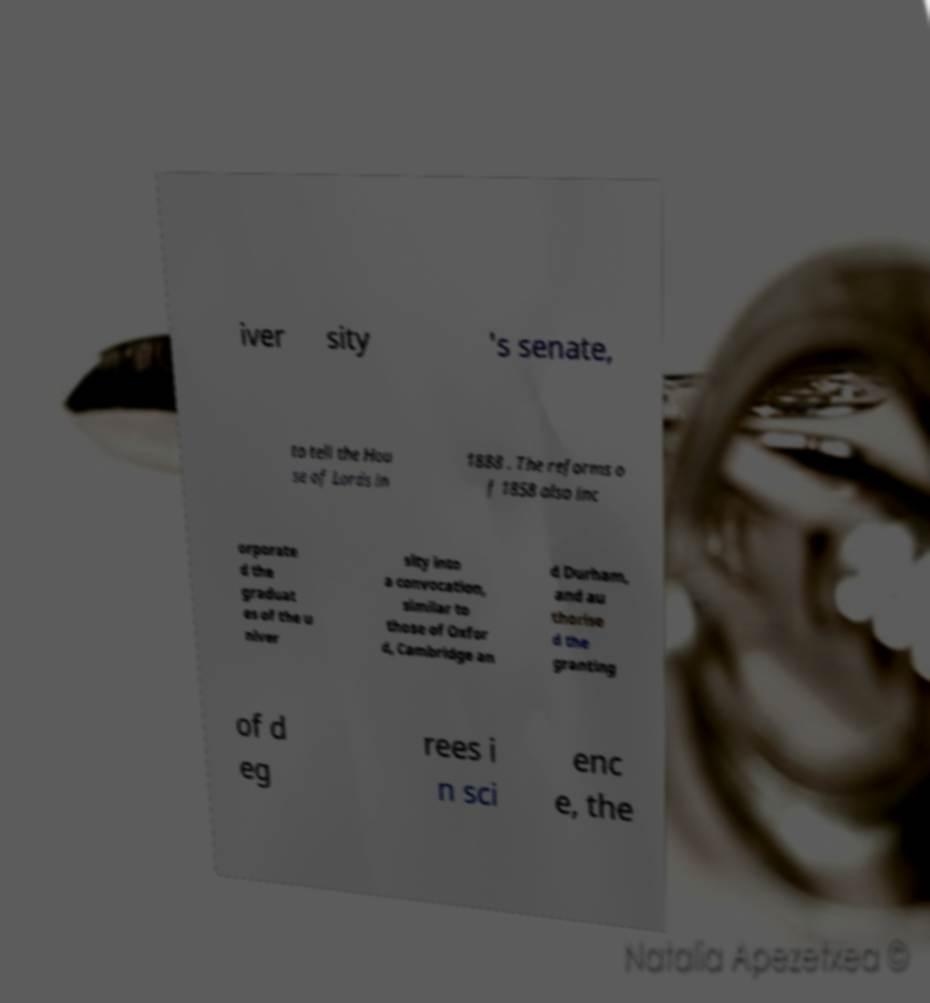What messages or text are displayed in this image? I need them in a readable, typed format. iver sity 's senate, to tell the Hou se of Lords in 1888 . The reforms o f 1858 also inc orporate d the graduat es of the u niver sity into a convocation, similar to those of Oxfor d, Cambridge an d Durham, and au thorise d the granting of d eg rees i n sci enc e, the 